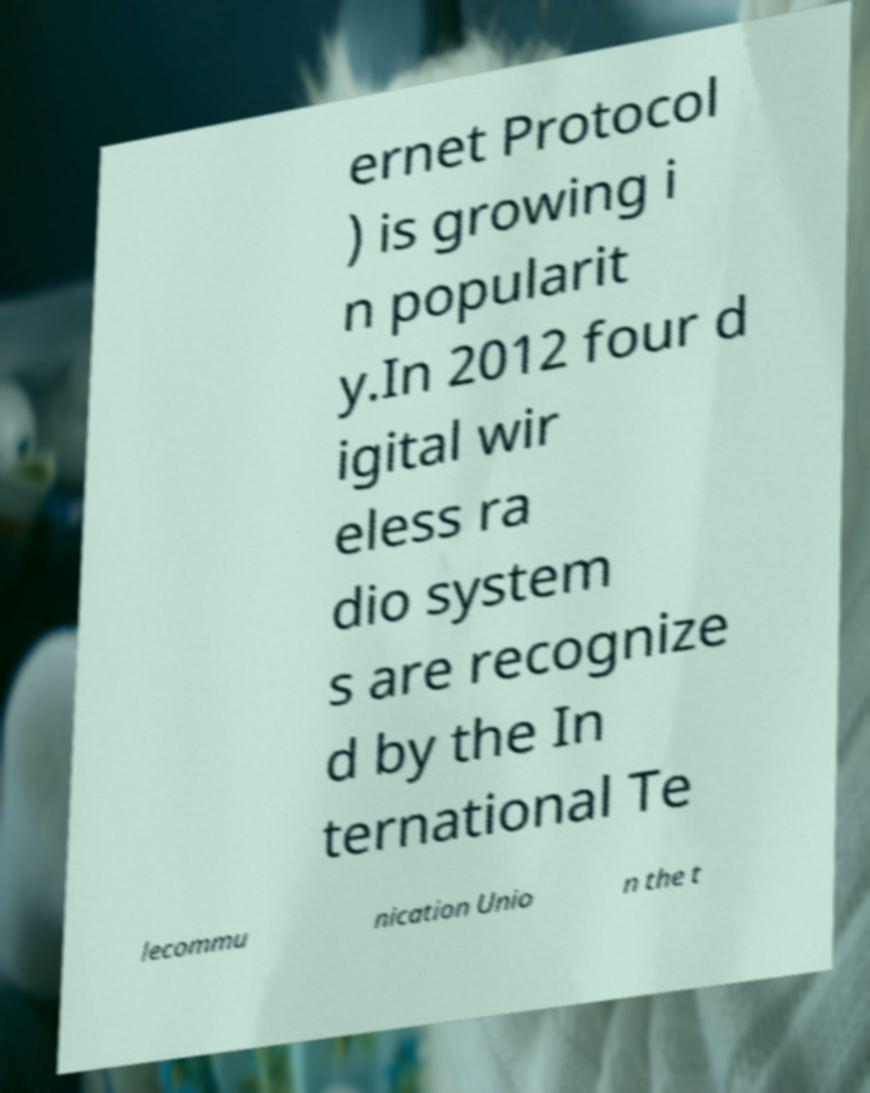Could you extract and type out the text from this image? ernet Protocol ) is growing i n popularit y.In 2012 four d igital wir eless ra dio system s are recognize d by the In ternational Te lecommu nication Unio n the t 